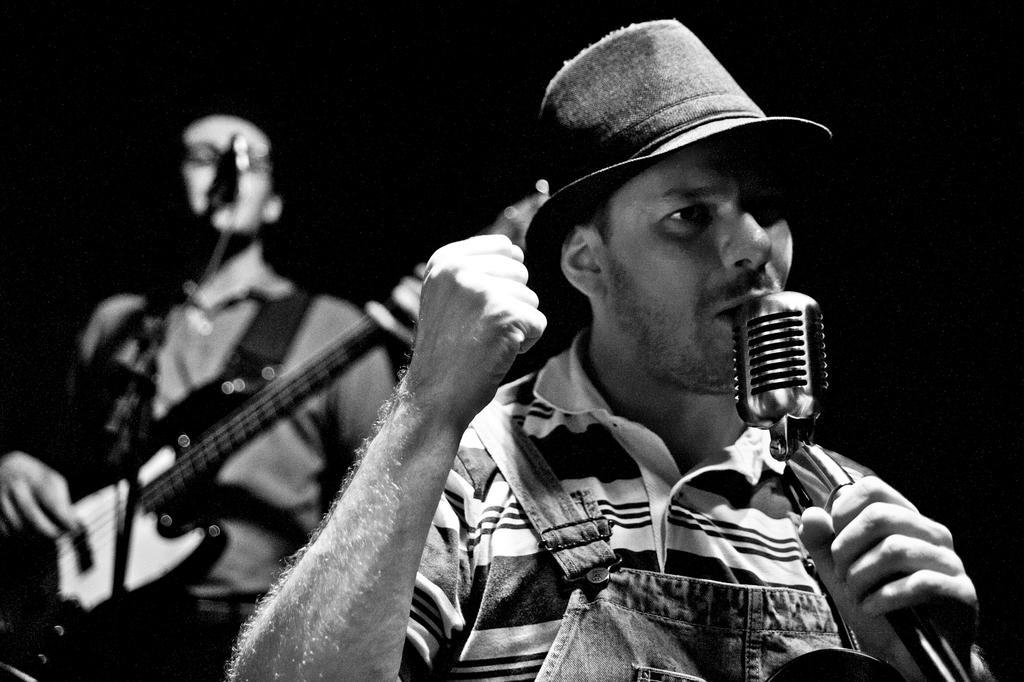Describe this image in one or two sentences. In this picture we can see two persons standing and singing on the mike. He wear a cap and he is playing guitar. 